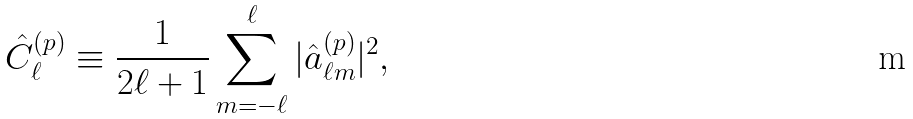Convert formula to latex. <formula><loc_0><loc_0><loc_500><loc_500>\hat { C } ^ { ( p ) } _ { \ell } \equiv \frac { 1 } { 2 \ell + 1 } \sum _ { m = - \ell } ^ { \ell } | \hat { a } ^ { ( p ) } _ { \ell m } | ^ { 2 } ,</formula> 